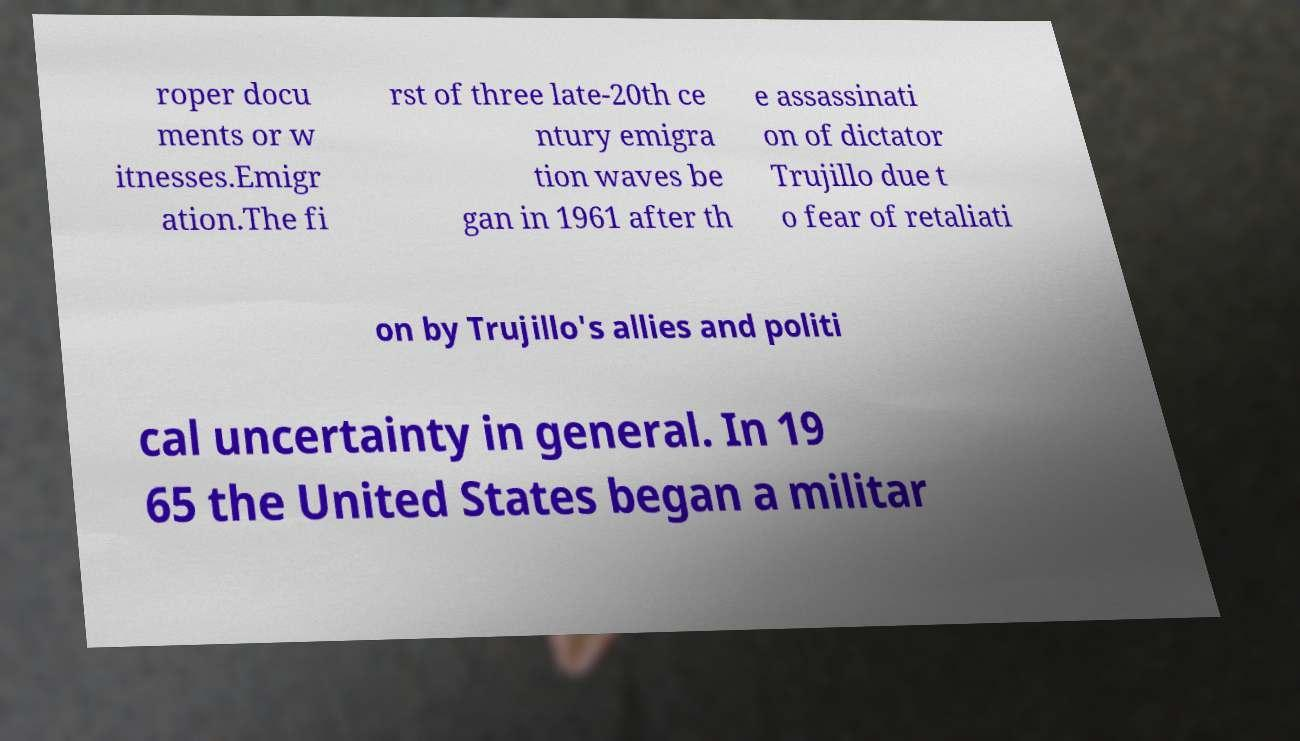I need the written content from this picture converted into text. Can you do that? roper docu ments or w itnesses.Emigr ation.The fi rst of three late-20th ce ntury emigra tion waves be gan in 1961 after th e assassinati on of dictator Trujillo due t o fear of retaliati on by Trujillo's allies and politi cal uncertainty in general. In 19 65 the United States began a militar 